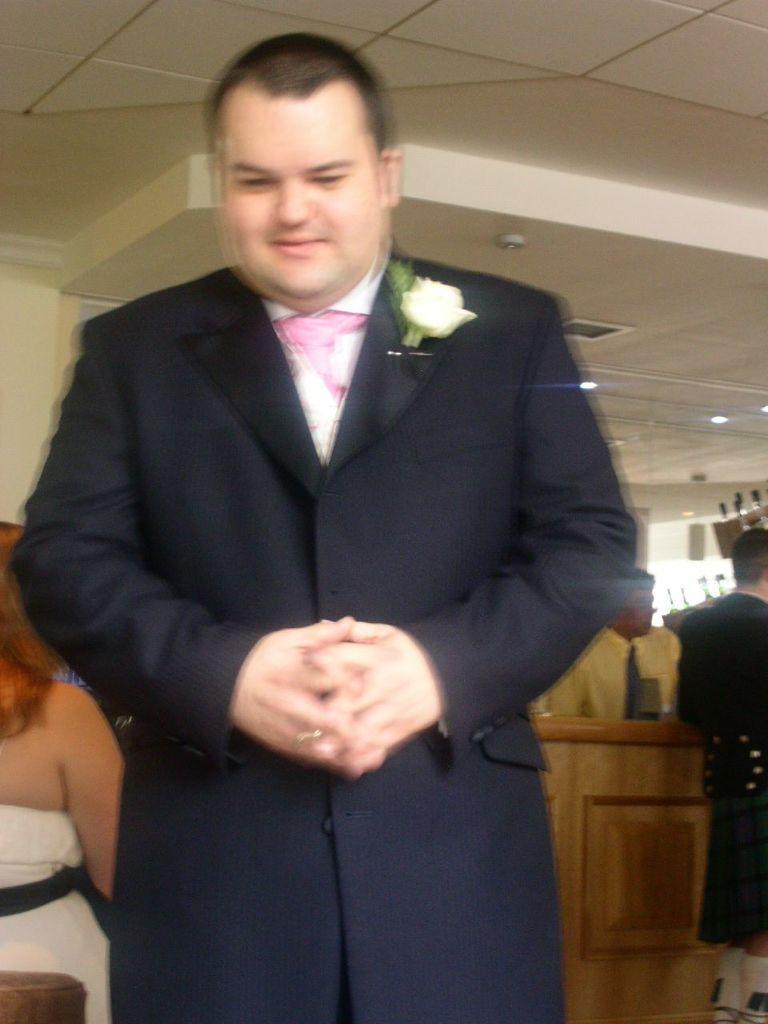Can you describe this image briefly? In this image in front there is a person. Behind him there are few other people. There is a wooden table. On top of the image there are fall ceiling lights. 